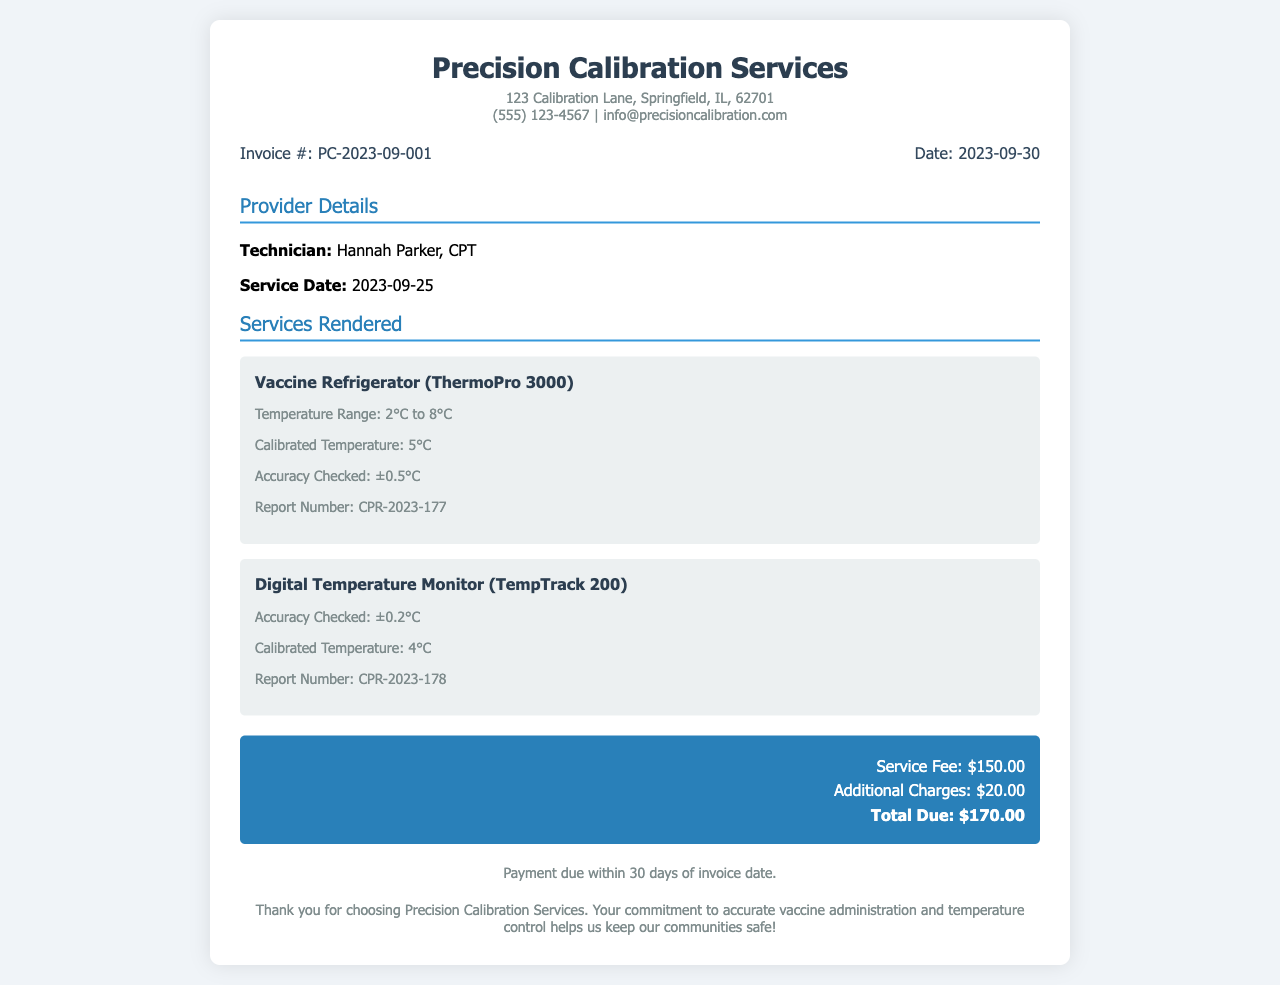What is the invoice number? The invoice number is specifically listed in the document as a unique identifier for this invoice.
Answer: PC-2023-09-001 Who is the technician? The technician is mentioned explicitly in the document, indicating the person who performed the calibration service.
Answer: Hannah Parker, CPT What is the service date? The service date, when the technician performed the calibration, is clearly stated in the document.
Answer: 2023-09-25 What is the calibrated temperature of the Vaccine Refrigerator? The calibrated temperature for the Vaccine Refrigerator is provided in the document under its service details.
Answer: 5°C What is the accuracy checked for the Digital Temperature Monitor? The accuracy check is detailed in the document for the Digital Temperature Monitor, providing insights into its performance.
Answer: ±0.2°C What is the total due amount? The total amount due for services rendered is summarized at the end of the invoice, indicating the total financial obligation.
Answer: $170.00 What are the payment terms? The payment terms outline the deadline for payment, which is specified in the document.
Answer: Payment due within 30 days of invoice date How much was the service fee? The service fee is explicitly listed as part of the total charges in the invoice.
Answer: $150.00 What is the report number for the Vaccine Refrigerator? Each calibration service includes a report number for documentation purposes, which is provided in the service details.
Answer: CPR-2023-177 